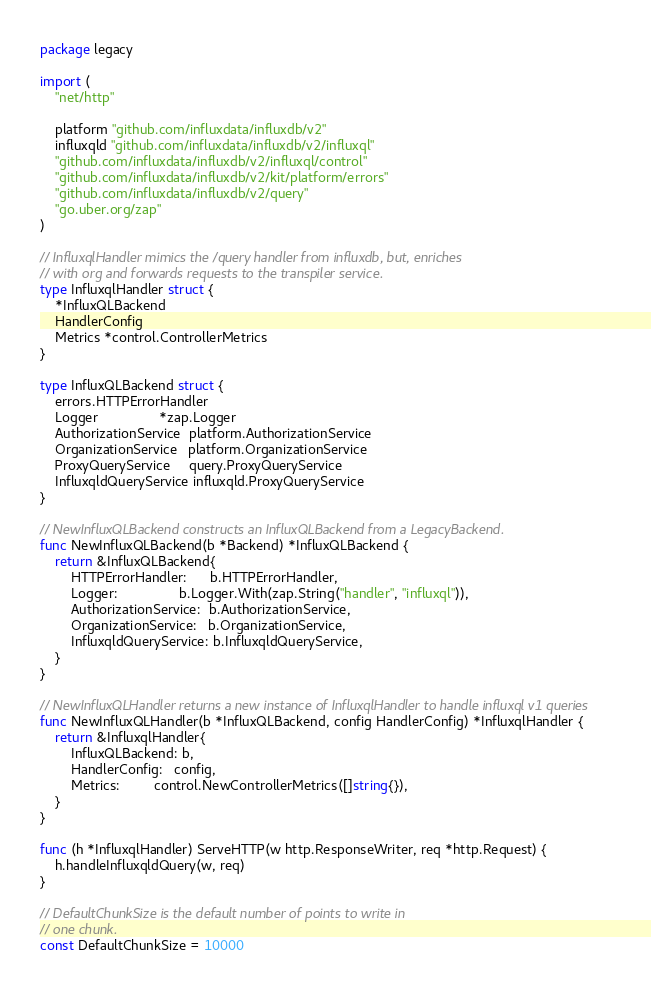Convert code to text. <code><loc_0><loc_0><loc_500><loc_500><_Go_>package legacy

import (
	"net/http"

	platform "github.com/influxdata/influxdb/v2"
	influxqld "github.com/influxdata/influxdb/v2/influxql"
	"github.com/influxdata/influxdb/v2/influxql/control"
	"github.com/influxdata/influxdb/v2/kit/platform/errors"
	"github.com/influxdata/influxdb/v2/query"
	"go.uber.org/zap"
)

// InfluxqlHandler mimics the /query handler from influxdb, but, enriches
// with org and forwards requests to the transpiler service.
type InfluxqlHandler struct {
	*InfluxQLBackend
	HandlerConfig
	Metrics *control.ControllerMetrics
}

type InfluxQLBackend struct {
	errors.HTTPErrorHandler
	Logger                *zap.Logger
	AuthorizationService  platform.AuthorizationService
	OrganizationService   platform.OrganizationService
	ProxyQueryService     query.ProxyQueryService
	InfluxqldQueryService influxqld.ProxyQueryService
}

// NewInfluxQLBackend constructs an InfluxQLBackend from a LegacyBackend.
func NewInfluxQLBackend(b *Backend) *InfluxQLBackend {
	return &InfluxQLBackend{
		HTTPErrorHandler:      b.HTTPErrorHandler,
		Logger:                b.Logger.With(zap.String("handler", "influxql")),
		AuthorizationService:  b.AuthorizationService,
		OrganizationService:   b.OrganizationService,
		InfluxqldQueryService: b.InfluxqldQueryService,
	}
}

// NewInfluxQLHandler returns a new instance of InfluxqlHandler to handle influxql v1 queries
func NewInfluxQLHandler(b *InfluxQLBackend, config HandlerConfig) *InfluxqlHandler {
	return &InfluxqlHandler{
		InfluxQLBackend: b,
		HandlerConfig:   config,
		Metrics:         control.NewControllerMetrics([]string{}),
	}
}

func (h *InfluxqlHandler) ServeHTTP(w http.ResponseWriter, req *http.Request) {
	h.handleInfluxqldQuery(w, req)
}

// DefaultChunkSize is the default number of points to write in
// one chunk.
const DefaultChunkSize = 10000
</code> 